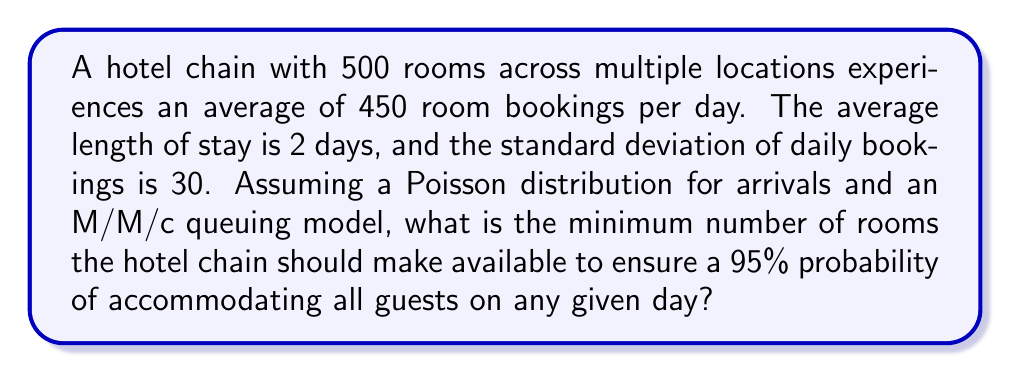Can you answer this question? To solve this problem, we'll use queuing theory and the normal approximation to the Poisson distribution. Let's break it down step-by-step:

1. Calculate the mean number of occupied rooms:
   $\mu = 450 \times 2 = 900$ rooms

2. Calculate the standard deviation of occupied rooms:
   $\sigma = \sqrt{450} \times 2 = \sqrt{1800} \approx 42.43$ rooms

3. For a 95% probability, we need to find the z-score:
   From the standard normal distribution table, z = 1.645 for 95% probability

4. Calculate the number of rooms needed using the formula:
   $\text{Rooms needed} = \mu + z \times \sigma$

5. Plug in the values:
   $\text{Rooms needed} = 900 + 1.645 \times 42.43 \approx 969.80$

6. Round up to the nearest whole number:
   $\text{Rooms needed} = 970$

Therefore, the hotel chain should make available at least 970 rooms to ensure a 95% probability of accommodating all guests on any given day.
Answer: 970 rooms 